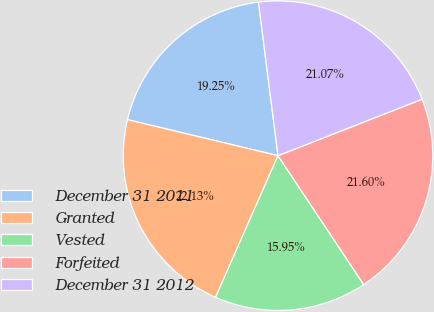Convert chart. <chart><loc_0><loc_0><loc_500><loc_500><pie_chart><fcel>December 31 2011<fcel>Granted<fcel>Vested<fcel>Forfeited<fcel>December 31 2012<nl><fcel>19.25%<fcel>22.13%<fcel>15.95%<fcel>21.6%<fcel>21.07%<nl></chart> 